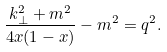Convert formula to latex. <formula><loc_0><loc_0><loc_500><loc_500>\frac { { k } _ { \perp } ^ { 2 } + m ^ { 2 } } { 4 x ( 1 - x ) } - m ^ { 2 } = { q } ^ { 2 } .</formula> 